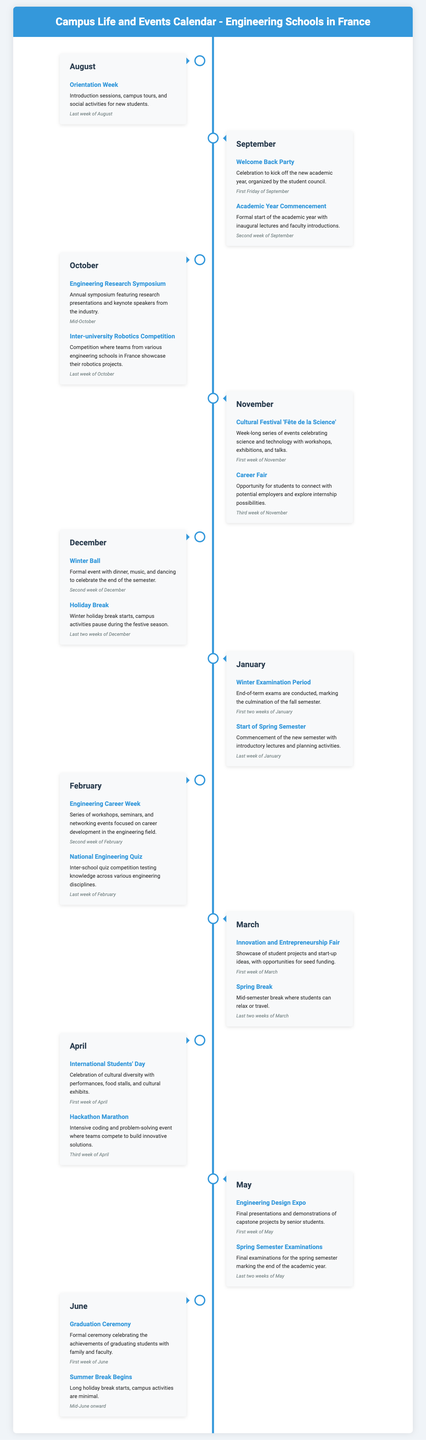What event marks the start of the academic year? The academic year begins with the formal start of the academic year and inaugural lectures.
Answer: Academic Year Commencement When does the holiday break begin? The holiday break starts during the festive season in December.
Answer: Last two weeks of December What is celebrated during the first week of April? In April, International Students' Day is celebrated to honor cultural diversity.
Answer: International Students' Day Which competition involves engineering students from various schools? The competition that involves teams from different engineering schools is the Inter-university Robotics Competition.
Answer: Inter-university Robotics Competition How long does the Winter Examination Period last? The Winter Examination Period lasts for the first two weeks of January.
Answer: First two weeks of January What type of event is held in November to connect students with employers? In November, a Career Fair is organized to help students connect with potential employers.
Answer: Career Fair What occurs during the second week of March? In March, students enjoy a mid-semester break called Spring Break.
Answer: Spring Break What kind of projects are showcased during the Innovation and Entrepreneurship Fair? The Innovation and Entrepreneurship Fair showcases student projects and start-up ideas.
Answer: Student projects and start-up ideas What is a key event held in mid-October? The key event held in mid-October is the Engineering Research Symposium.
Answer: Engineering Research Symposium 